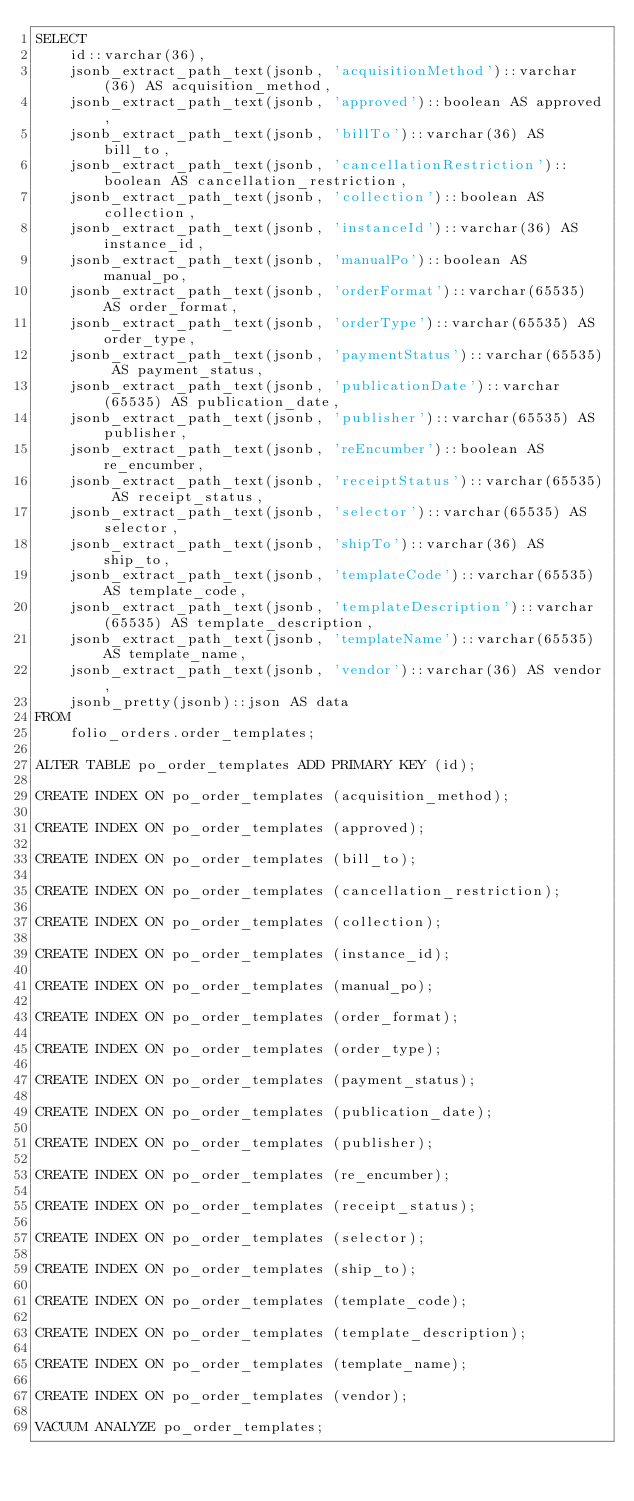<code> <loc_0><loc_0><loc_500><loc_500><_SQL_>SELECT
    id::varchar(36),
    jsonb_extract_path_text(jsonb, 'acquisitionMethod')::varchar(36) AS acquisition_method,
    jsonb_extract_path_text(jsonb, 'approved')::boolean AS approved,
    jsonb_extract_path_text(jsonb, 'billTo')::varchar(36) AS bill_to,
    jsonb_extract_path_text(jsonb, 'cancellationRestriction')::boolean AS cancellation_restriction,
    jsonb_extract_path_text(jsonb, 'collection')::boolean AS collection,
    jsonb_extract_path_text(jsonb, 'instanceId')::varchar(36) AS instance_id,
    jsonb_extract_path_text(jsonb, 'manualPo')::boolean AS manual_po,
    jsonb_extract_path_text(jsonb, 'orderFormat')::varchar(65535) AS order_format,
    jsonb_extract_path_text(jsonb, 'orderType')::varchar(65535) AS order_type,
    jsonb_extract_path_text(jsonb, 'paymentStatus')::varchar(65535) AS payment_status,
    jsonb_extract_path_text(jsonb, 'publicationDate')::varchar(65535) AS publication_date,
    jsonb_extract_path_text(jsonb, 'publisher')::varchar(65535) AS publisher,
    jsonb_extract_path_text(jsonb, 'reEncumber')::boolean AS re_encumber,
    jsonb_extract_path_text(jsonb, 'receiptStatus')::varchar(65535) AS receipt_status,
    jsonb_extract_path_text(jsonb, 'selector')::varchar(65535) AS selector,
    jsonb_extract_path_text(jsonb, 'shipTo')::varchar(36) AS ship_to,
    jsonb_extract_path_text(jsonb, 'templateCode')::varchar(65535) AS template_code,
    jsonb_extract_path_text(jsonb, 'templateDescription')::varchar(65535) AS template_description,
    jsonb_extract_path_text(jsonb, 'templateName')::varchar(65535) AS template_name,
    jsonb_extract_path_text(jsonb, 'vendor')::varchar(36) AS vendor,
    jsonb_pretty(jsonb)::json AS data
FROM
    folio_orders.order_templates;

ALTER TABLE po_order_templates ADD PRIMARY KEY (id);

CREATE INDEX ON po_order_templates (acquisition_method);

CREATE INDEX ON po_order_templates (approved);

CREATE INDEX ON po_order_templates (bill_to);

CREATE INDEX ON po_order_templates (cancellation_restriction);

CREATE INDEX ON po_order_templates (collection);

CREATE INDEX ON po_order_templates (instance_id);

CREATE INDEX ON po_order_templates (manual_po);

CREATE INDEX ON po_order_templates (order_format);

CREATE INDEX ON po_order_templates (order_type);

CREATE INDEX ON po_order_templates (payment_status);

CREATE INDEX ON po_order_templates (publication_date);

CREATE INDEX ON po_order_templates (publisher);

CREATE INDEX ON po_order_templates (re_encumber);

CREATE INDEX ON po_order_templates (receipt_status);

CREATE INDEX ON po_order_templates (selector);

CREATE INDEX ON po_order_templates (ship_to);

CREATE INDEX ON po_order_templates (template_code);

CREATE INDEX ON po_order_templates (template_description);

CREATE INDEX ON po_order_templates (template_name);

CREATE INDEX ON po_order_templates (vendor);

VACUUM ANALYZE po_order_templates;
</code> 